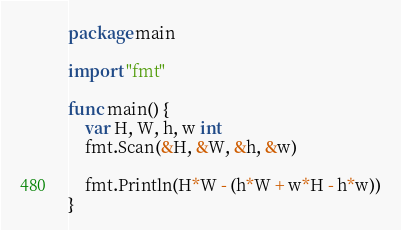Convert code to text. <code><loc_0><loc_0><loc_500><loc_500><_Go_>package main

import "fmt"

func main() {
	var H, W, h, w int
	fmt.Scan(&H, &W, &h, &w)

	fmt.Println(H*W - (h*W + w*H - h*w))
}</code> 